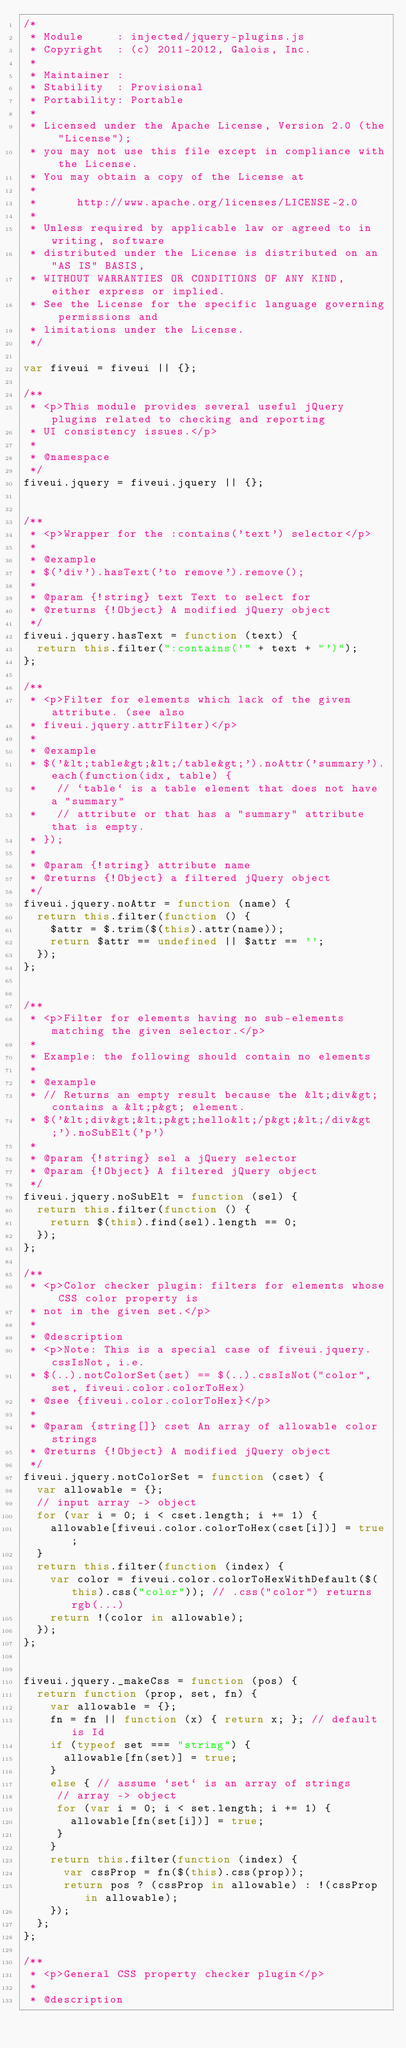Convert code to text. <code><loc_0><loc_0><loc_500><loc_500><_JavaScript_>/*
 * Module     : injected/jquery-plugins.js
 * Copyright  : (c) 2011-2012, Galois, Inc.
 *
 * Maintainer :
 * Stability  : Provisional
 * Portability: Portable
 *
 * Licensed under the Apache License, Version 2.0 (the "License");
 * you may not use this file except in compliance with the License.
 * You may obtain a copy of the License at
 *
 *      http://www.apache.org/licenses/LICENSE-2.0
 *
 * Unless required by applicable law or agreed to in writing, software
 * distributed under the License is distributed on an "AS IS" BASIS,
 * WITHOUT WARRANTIES OR CONDITIONS OF ANY KIND, either express or implied.
 * See the License for the specific language governing permissions and
 * limitations under the License.
 */

var fiveui = fiveui || {};

/**
 * <p>This module provides several useful jQuery plugins related to checking and reporting
 * UI consistency issues.</p>
 *
 * @namespace
 */
fiveui.jquery = fiveui.jquery || {};


/**
 * <p>Wrapper for the :contains('text') selector</p>
 *
 * @example
 * $('div').hasText('to remove').remove();
 *
 * @param {!string} text Text to select for
 * @returns {!Object} A modified jQuery object
 */
fiveui.jquery.hasText = function (text) {
  return this.filter(":contains('" + text + "')");
};

/**
 * <p>Filter for elements which lack of the given attribute. (see also
 * fiveui.jquery.attrFilter)</p>
 *
 * @example
 * $('&lt;table&gt;&lt;/table&gt;').noAttr('summary').each(function(idx, table) {
 *   // `table` is a table element that does not have a "summary"
 *   // attribute or that has a "summary" attribute that is empty.
 * });
 *
 * @param {!string} attribute name
 * @returns {!Object} a filtered jQuery object
 */
fiveui.jquery.noAttr = function (name) {
  return this.filter(function () {
    $attr = $.trim($(this).attr(name));
    return $attr == undefined || $attr == '';
  });
};


/**
 * <p>Filter for elements having no sub-elements matching the given selector.</p>
 *
 * Example: the following should contain no elements
 *
 * @example
 * // Returns an empty result because the &lt;div&gt; contains a &lt;p&gt; element.
 * $('&lt;div&gt;&lt;p&gt;hello&lt;/p&gt;&lt;/div&gt;').noSubElt('p')
 *
 * @param {!string} sel a jQuery selector
 * @param {!Object} A filtered jQuery object
 */
fiveui.jquery.noSubElt = function (sel) {
  return this.filter(function () {
    return $(this).find(sel).length == 0;
  });
};

/**
 * <p>Color checker plugin: filters for elements whose CSS color property is
 * not in the given set.</p>
 *
 * @description
 * <p>Note: This is a special case of fiveui.jquery.cssIsNot, i.e.
 * $(..).notColorSet(set) == $(..).cssIsNot("color", set, fiveui.color.colorToHex)
 * @see {fiveui.color.colorToHex}</p>
 *
 * @param {string[]} cset An array of allowable color strings
 * @returns {!Object} A modified jQuery object
 */
fiveui.jquery.notColorSet = function (cset) {
  var allowable = {};
  // input array -> object
  for (var i = 0; i < cset.length; i += 1) {
    allowable[fiveui.color.colorToHex(cset[i])] = true;
  }
  return this.filter(function (index) {
    var color = fiveui.color.colorToHexWithDefault($(this).css("color")); // .css("color") returns rgb(...)
    return !(color in allowable);
  });
};


fiveui.jquery._makeCss = function (pos) {
  return function (prop, set, fn) {
    var allowable = {};
    fn = fn || function (x) { return x; }; // default is Id
    if (typeof set === "string") {
      allowable[fn(set)] = true;
    }
    else { // assume `set` is an array of strings
     // array -> object
     for (var i = 0; i < set.length; i += 1) {
       allowable[fn(set[i])] = true;
     }
    }
    return this.filter(function (index) {
      var cssProp = fn($(this).css(prop));
      return pos ? (cssProp in allowable) : !(cssProp in allowable);
    });
  };
};

/**
 * <p>General CSS property checker plugin</p>
 *
 * @description</code> 